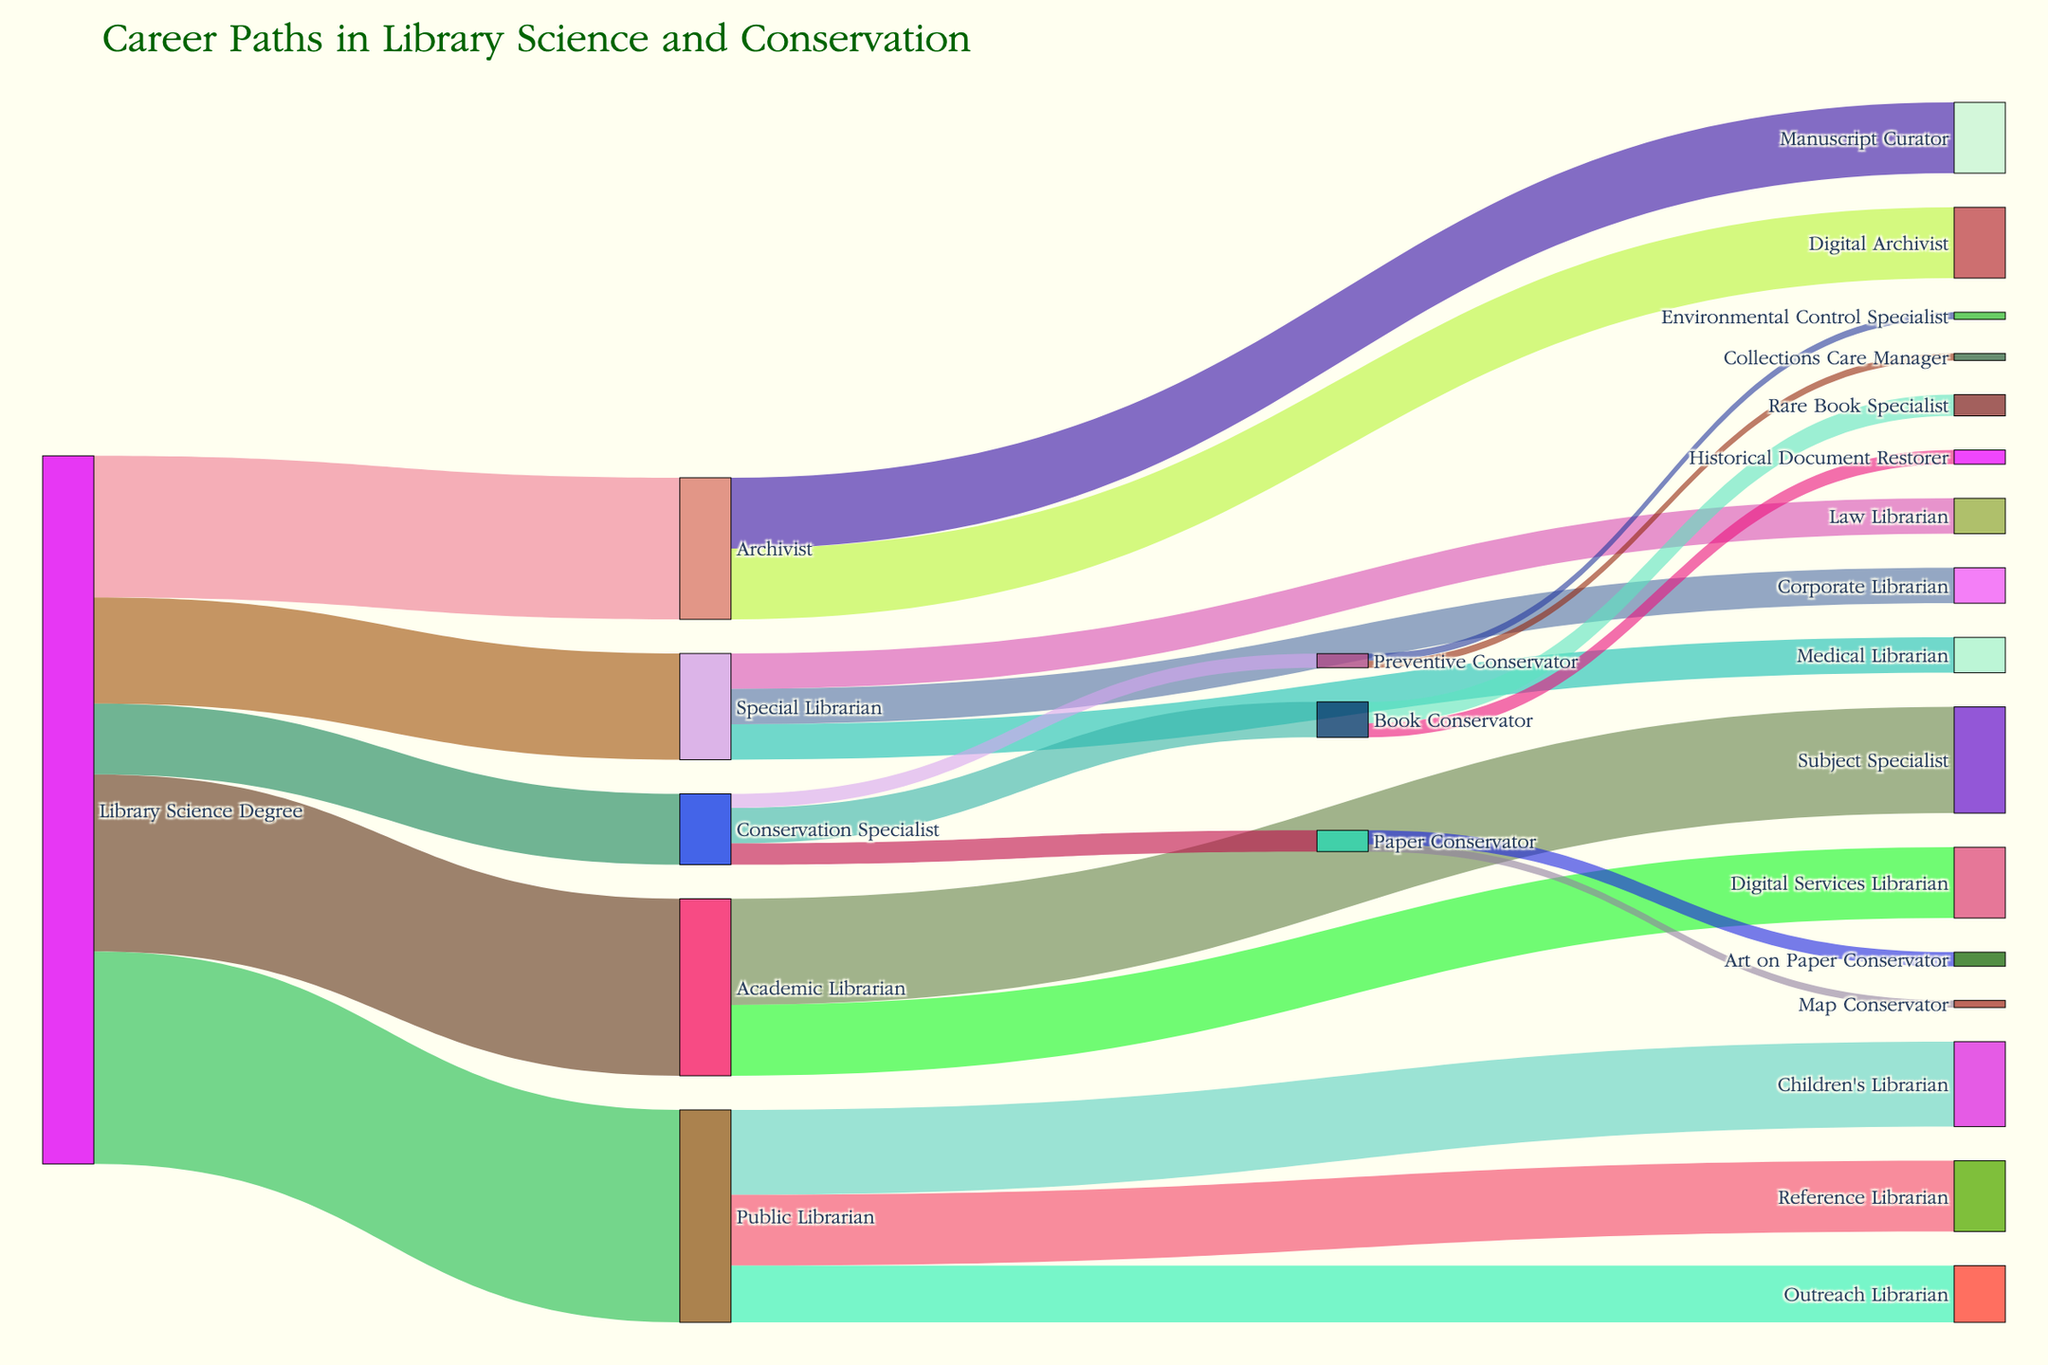What's the title of the figure? There is a title at the top of the figure that describes the overall content of the Sankey Diagram.
Answer: Career Paths in Library Science and Conservation Which career path has the highest number of transitions from a Library Science Degree? Each branch originating from "Library Science Degree" is labeled, and by examining the values, "Public Librarian" has the highest number (30).
Answer: Public Librarian How many career specializations are there within the role of an Academic Librarian? Follow the branch from "Academic Librarian" to see the specializations, which are "Subject Specialist" and "Digital Services Librarian". Count them.
Answer: 2 What is the sum of values for all specializations within the role of a Conservation Specialist? Follow the branch from "Conservation Specialist" to its specializations: "Book Conservator" (5), "Paper Conservator" (3), and "Preventive Conservator" (2). Summing these gives 5 + 3 + 2.
Answer: 10 Which specialization from an Archivist has the same value as a Paper Conservator? Follow the branches from "Archivist" and compare their values to those from "Paper Conservator", which has a value of 3. "Manuscript Curator" has a value of 10, "Digital Archivist" has 10, and no direct match is found.
Answer: None What percentage of Library Science Degree holders become Special Librarians? The value for "Special Librarian" is 15 out of a total of 100 (sum of all immediate transitions from "Library Science Degree"). Calculation: (15/100) * 100%.
Answer: 15% Which career path has more transitions: Children's Librarian or Historical Document Restorer? Compare the values from their respective branches: "Children's Librarian" has 12, and "Historical Document Restorer" has 2.
Answer: Children’s Librarian What is the total number of transitions to specialized roles from Public Librarians? The specializations from "Public Librarian" are "Children's Librarian" (12), "Reference Librarian" (10), and "Outreach Librarian" (8). Sum these values: 12 + 10 + 8.
Answer: 30 Which specialization of Conservation Specialists has the least number of transitions? Follow the branches from "Conservation Specialist" and compare the values: "Book Conservator" (5), "Paper Conservator" (3), "Preventive Conservator" (2). The least number of transitions is in "Preventive Conservator".
Answer: Preventive Conservator 